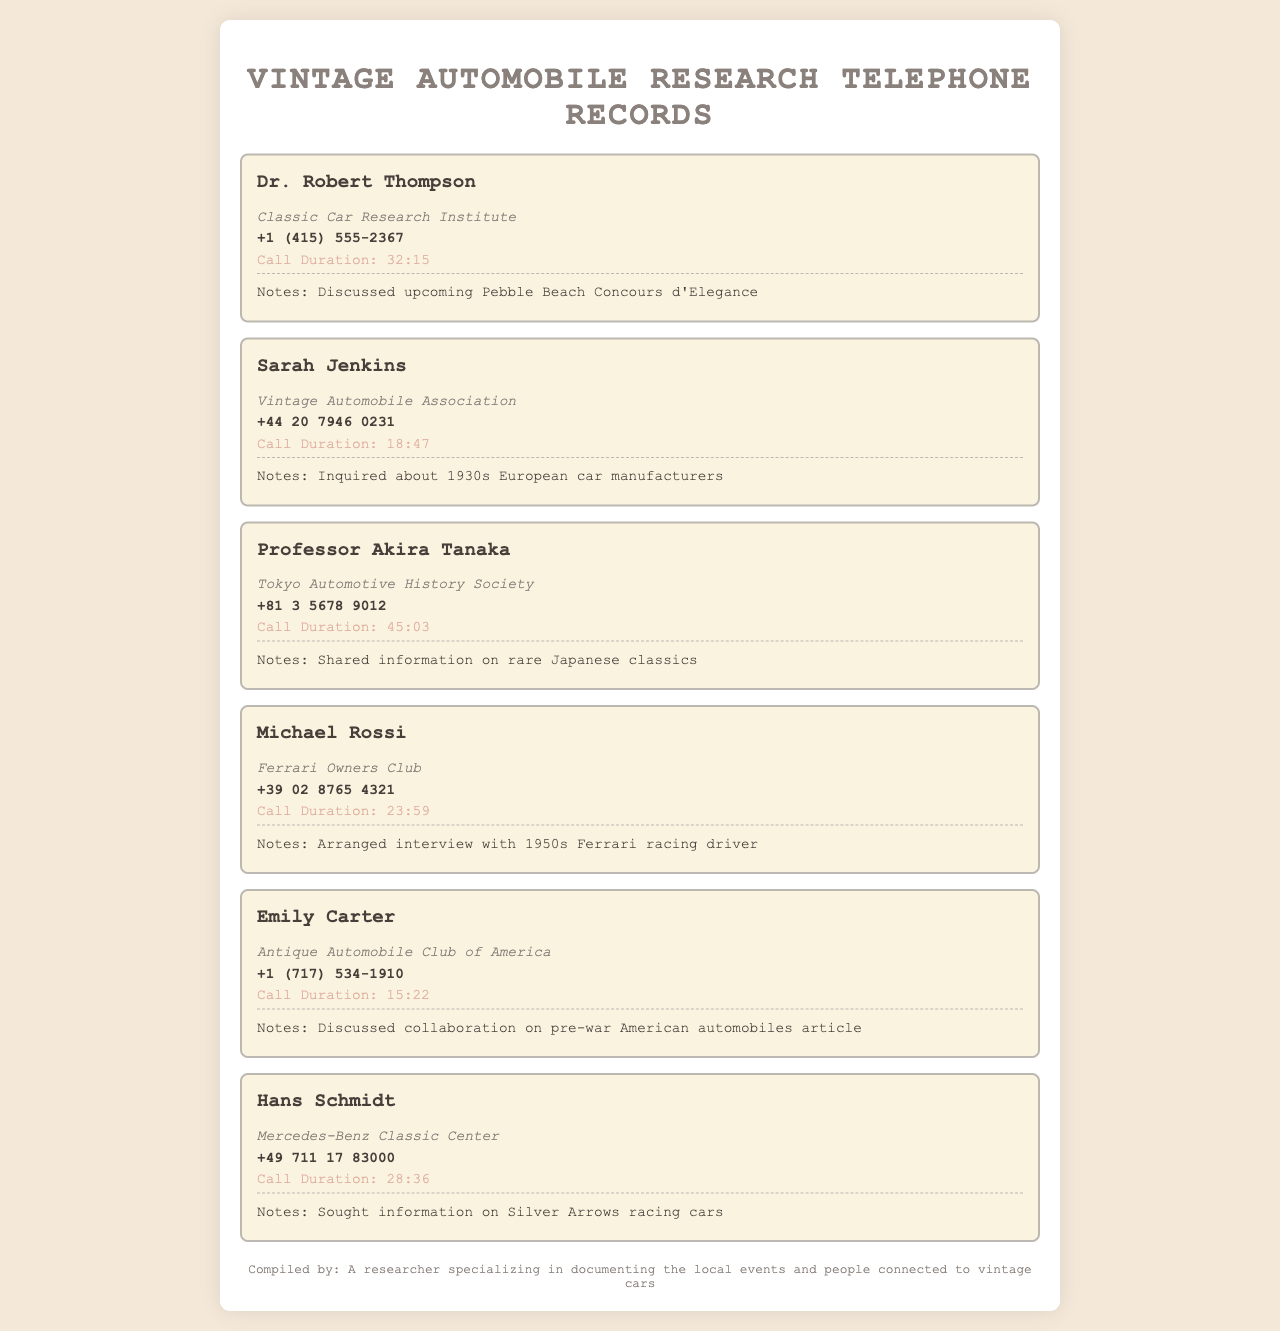What is the organization of Dr. Robert Thompson? Dr. Robert Thompson is associated with the Classic Car Research Institute as listed in the document.
Answer: Classic Car Research Institute How long was the call with Professor Akira Tanaka? The duration of the call with Professor Akira Tanaka is explicitly stated in the document.
Answer: 45:03 Who in the document is connected to Ferrari? Michael Rossi is mentioned to be affiliated with the Ferrari Owners Club in the document.
Answer: Michael Rossi What was discussed during the call with Emily Carter? The document notes that the call with Emily Carter involved collaboration on a specific article topic.
Answer: Collaboration on pre-war American automobiles article What is the phone number for Sarah Jenkins? The document provides the phone number for Sarah Jenkins, which can be retrieved directly from the entry.
Answer: +44 20 7946 0231 Which individual talked about Japanese classic cars? The document indicates that Professor Akira Tanaka shared information about rare Japanese classics during a call.
Answer: Professor Akira Tanaka How many people are listed in the telephone records? The total entries in the document give the count of individuals listed in the telephone records.
Answer: Six What kind of information did Hans Schmidt seek during his call? The notes for Hans Schmidt's call specifically mention the type of information he was interested in.
Answer: Silver Arrows racing cars What is the overall theme of the document? The document is centered around telephone records related to engagements in vintage automobile research.
Answer: Vintage automobile research 